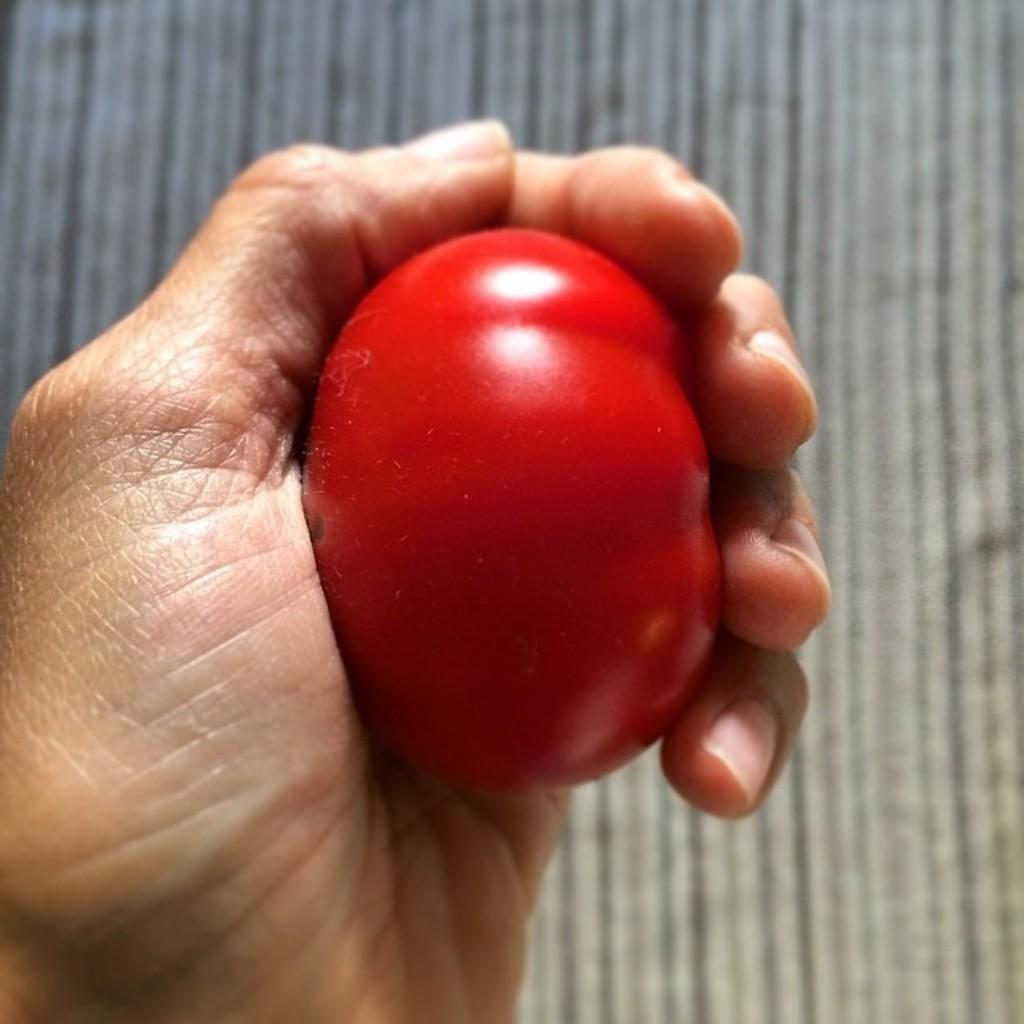Who or what is the main subject in the image? There is a person in the image. What is the person holding in the image? The person is holding a tomato. What can be seen in the background of the image? There are lights visible in the background of the image. How many cherries are on the wire in the image? There is no wire or cherries present in the image. 